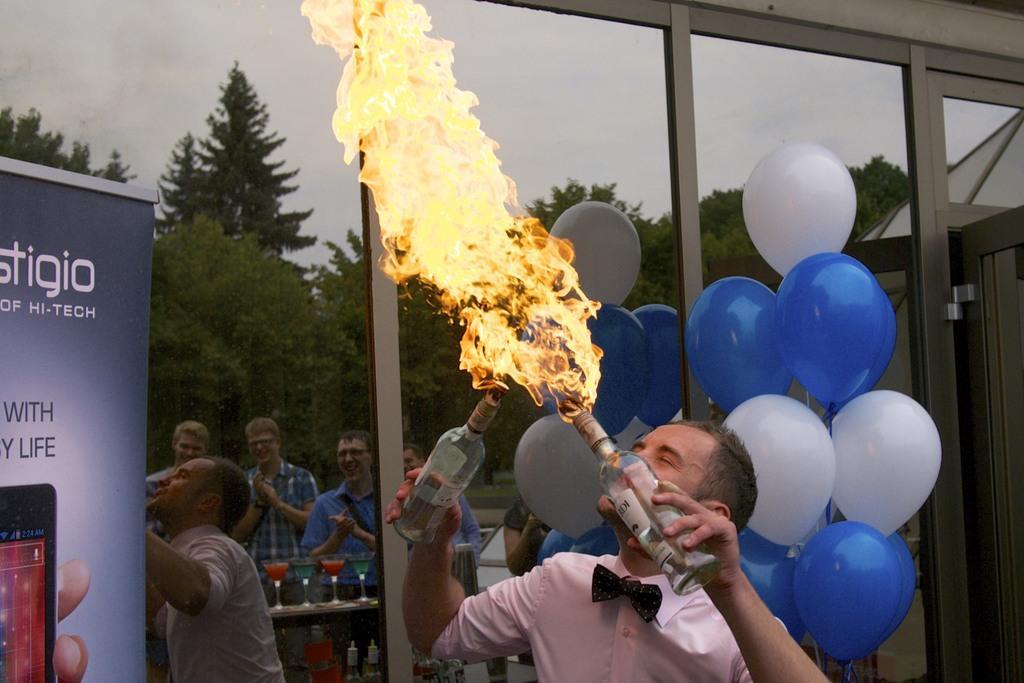Please provide a concise description of this image. In the picture we can see a man holding a two bottles with fire and performing, back side we can see a balloons and glass door and we can also see some people standing. 